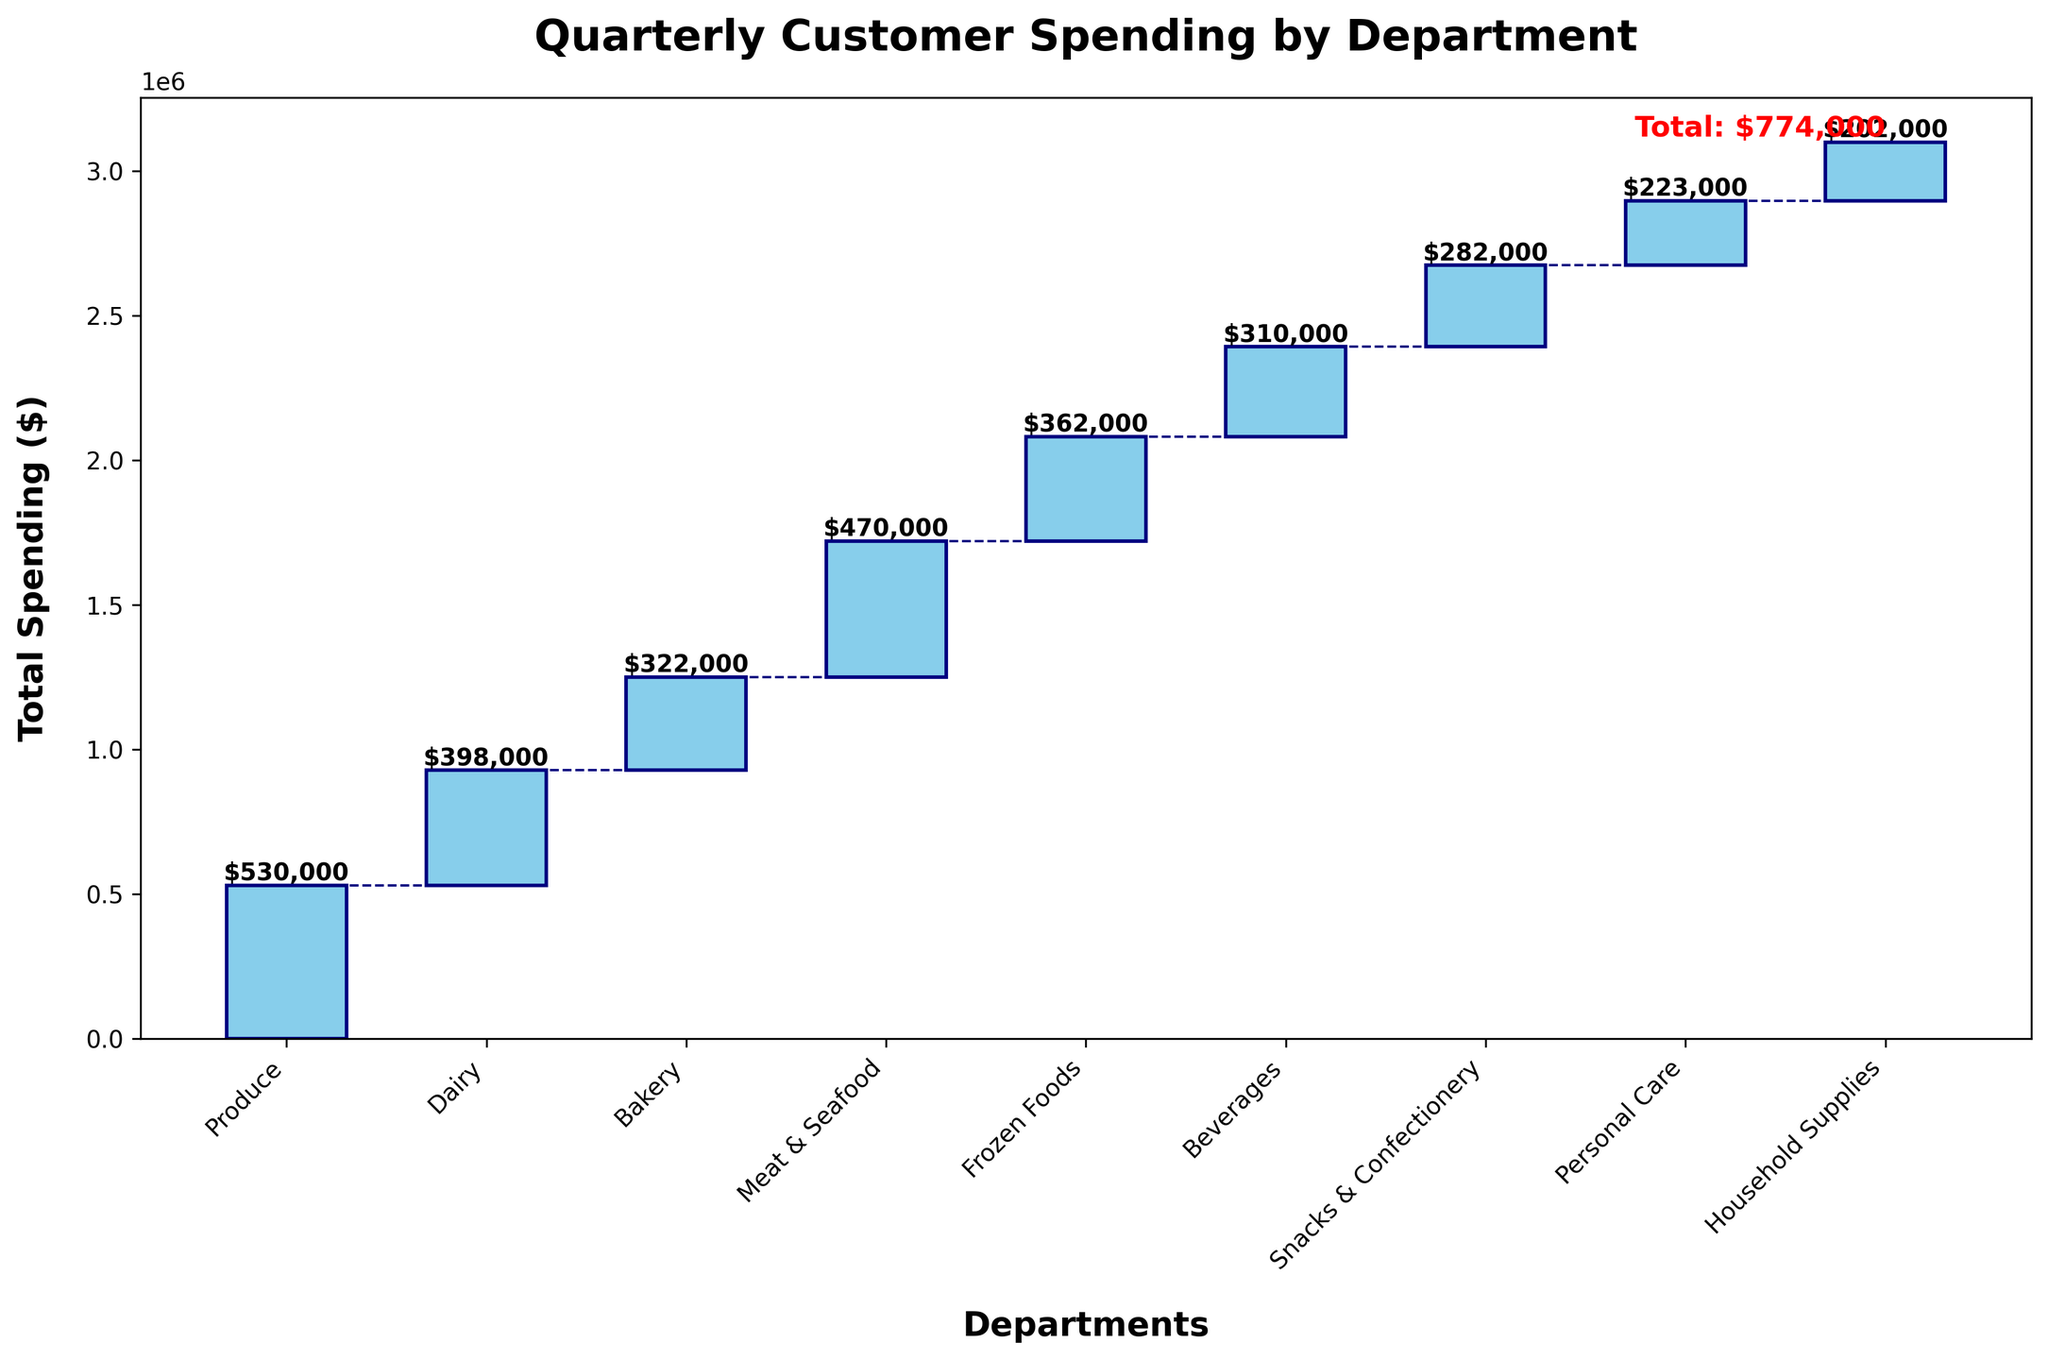what is the main title of the chart? The title is displayed at the top of the chart in a larger, bold font that helps in identifying the main subject.
Answer: Quarterly Customer Spending by Department which department had the highest spending in Q1? By looking at the tallest bar corresponding to Q1, which in this case is for Produce, we can determine which department had the highest spending in Q1.
Answer: Produce What is the cumulative spending after adding Dairy's contribution in Q1? Starting from a cumulative amount of $125,000 for Produce and adding Dairy's $95,000 spending in Q1 gives us $220,000.
Answer: $220,000 Which two departments together contribute more than $200,000 in total spending in Q3? We need to check each pair of department spending values in Q3. Produce ($140,000) and Dairy ($105,000) together contribute $245,000.
Answer: Produce and Dairy How does Bakery's spending in Q4 compare to Bakery's spending in Q1? By comparing the height of the Bakery bars in Q1 ($75,000) and Q4 ($82,000), we can see which one is greater.
Answer: Q4's Bakery spending is higher What is the total spending for the Meat & Seafood department over the four quarters? Sum the Meat & Seafood values for each quarter: $110,000 (Q1) + $120,000 (Q2) + $125,000 (Q3) + $115,000 (Q4).
Answer: $470,000 How much did Personal Care spending increase from Q1 to Q4? Subtract the Personal Care spending in Q1 ($50,000) from that in Q4 ($58,000).
Answer: $8,000 Which quarter saw the lowest total spending? Compare the total spending amounts given in the "Total" row for each quarter: Q1 ($720,000), Q2 ($780,000), Q3 ($825,000), Q4 ($774,000).
Answer: Q1 Which department has the smallest portion of spending across all quarters? By evaluating the height of each department's bars across all quarters, the smallest portion belongs to Household Supplies with lower values consistently.
Answer: Household Supplies 